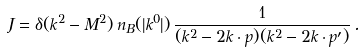Convert formula to latex. <formula><loc_0><loc_0><loc_500><loc_500>J = \delta ( k ^ { 2 } - M ^ { 2 } ) \, n _ { B } ( | k ^ { 0 } | ) \, \frac { 1 } { ( k ^ { 2 } - 2 k \cdot p ) ( k ^ { 2 } - 2 k \cdot p ^ { \prime } ) } \, .</formula> 